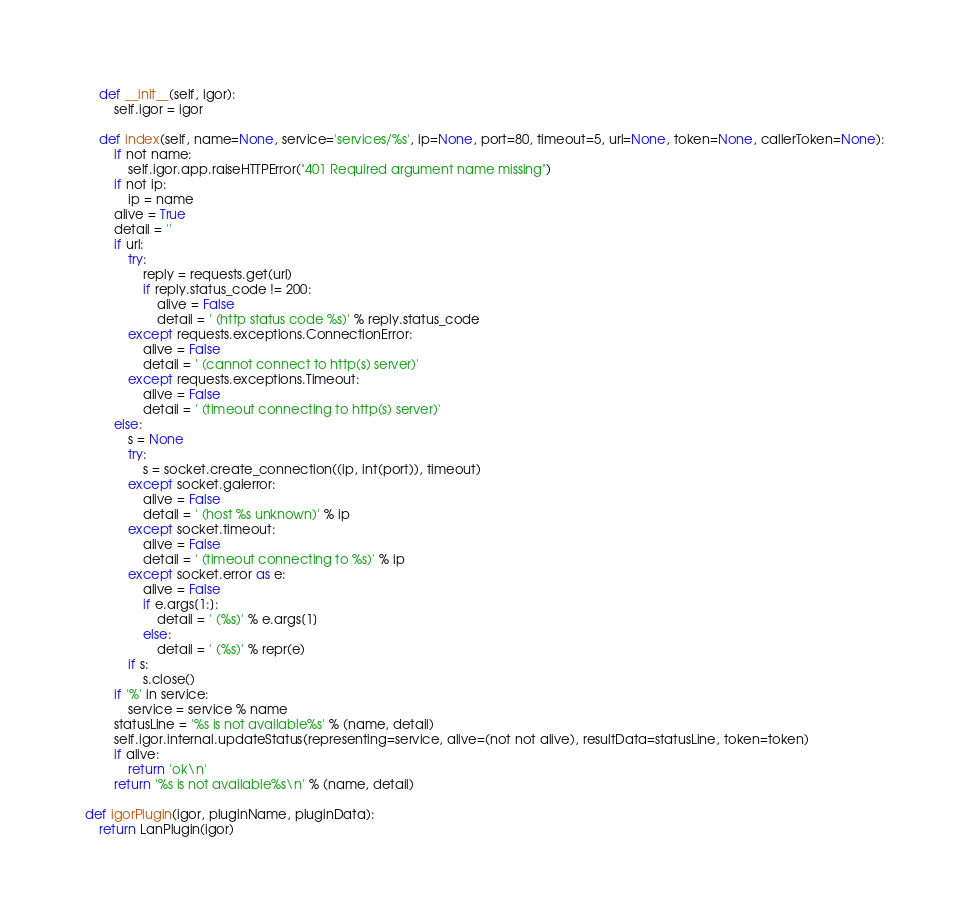<code> <loc_0><loc_0><loc_500><loc_500><_Python_>    def __init__(self, igor):
        self.igor = igor
        
    def index(self, name=None, service='services/%s', ip=None, port=80, timeout=5, url=None, token=None, callerToken=None):
        if not name:
            self.igor.app.raiseHTTPError("401 Required argument name missing")
        if not ip:
            ip = name
        alive = True
        detail = ''
        if url:
            try:
                reply = requests.get(url)
                if reply.status_code != 200:
                    alive = False
                    detail = ' (http status code %s)' % reply.status_code
            except requests.exceptions.ConnectionError:
                alive = False
                detail = ' (cannot connect to http(s) server)'
            except requests.exceptions.Timeout:
                alive = False
                detail = ' (timeout connecting to http(s) server)'
        else:
            s = None
            try:
                s = socket.create_connection((ip, int(port)), timeout)
            except socket.gaierror:
                alive = False
                detail = ' (host %s unknown)' % ip
            except socket.timeout:
                alive = False
                detail = ' (timeout connecting to %s)' % ip
            except socket.error as e:
                alive = False
                if e.args[1:]:
                    detail = ' (%s)' % e.args[1]
                else:
                    detail = ' (%s)' % repr(e)
            if s:
                s.close()
        if '%' in service:
            service = service % name
        statusLine = '%s is not available%s' % (name, detail)
        self.igor.internal.updateStatus(representing=service, alive=(not not alive), resultData=statusLine, token=token)
        if alive:
            return 'ok\n'
        return '%s is not available%s\n' % (name, detail)
    
def igorPlugin(igor, pluginName, pluginData):
    return LanPlugin(igor)
</code> 